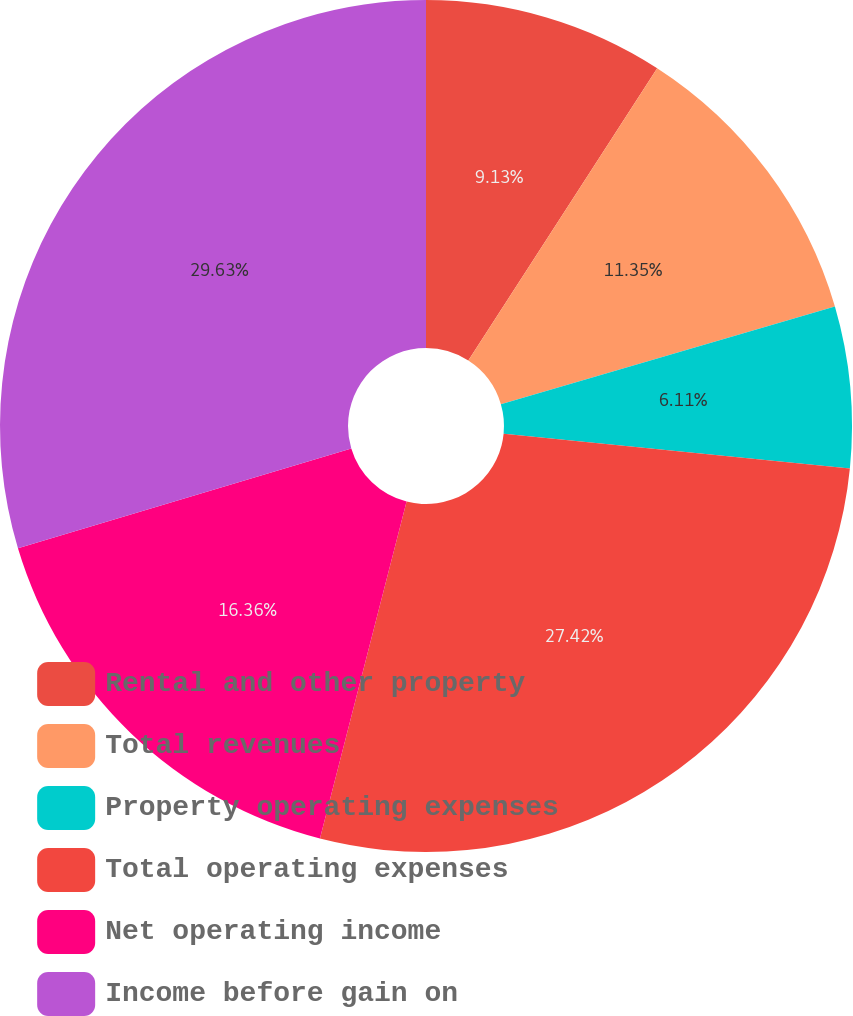Convert chart. <chart><loc_0><loc_0><loc_500><loc_500><pie_chart><fcel>Rental and other property<fcel>Total revenues<fcel>Property operating expenses<fcel>Total operating expenses<fcel>Net operating income<fcel>Income before gain on<nl><fcel>9.13%<fcel>11.35%<fcel>6.11%<fcel>27.42%<fcel>16.36%<fcel>29.64%<nl></chart> 